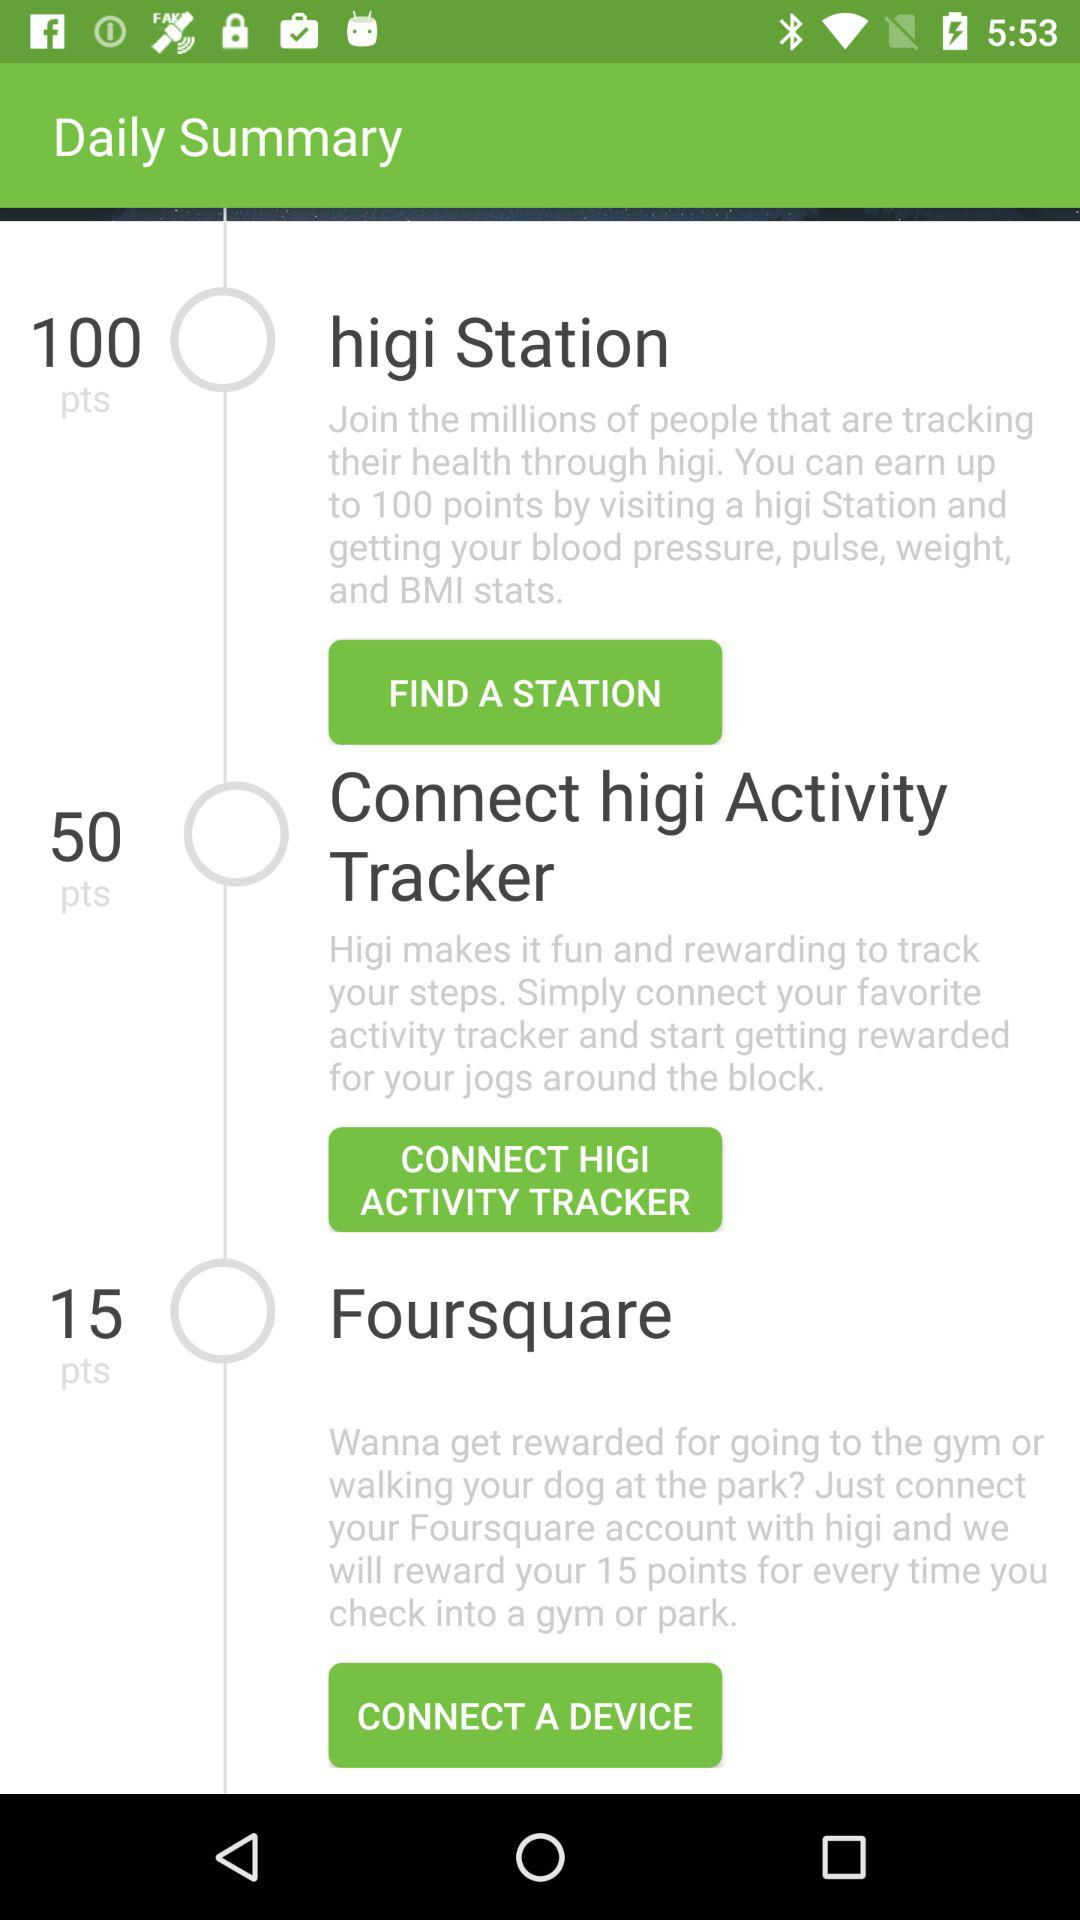How many points can I earn by connecting my nggi Activity Tracker?
Answer the question using a single word or phrase. 50 